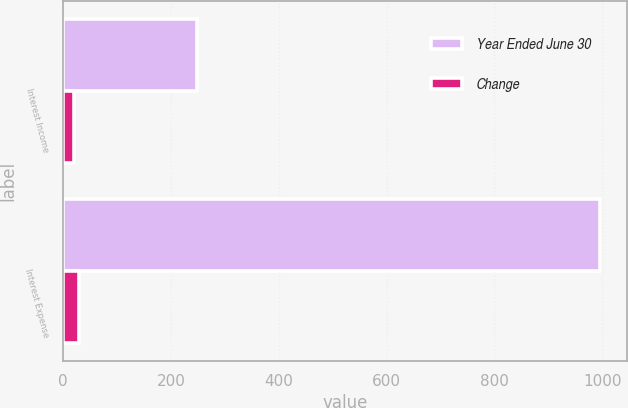Convert chart. <chart><loc_0><loc_0><loc_500><loc_500><stacked_bar_chart><ecel><fcel>Interest Income<fcel>Interest Expense<nl><fcel>Year Ended June 30<fcel>248<fcel>996<nl><fcel>Change<fcel>19<fcel>30<nl></chart> 